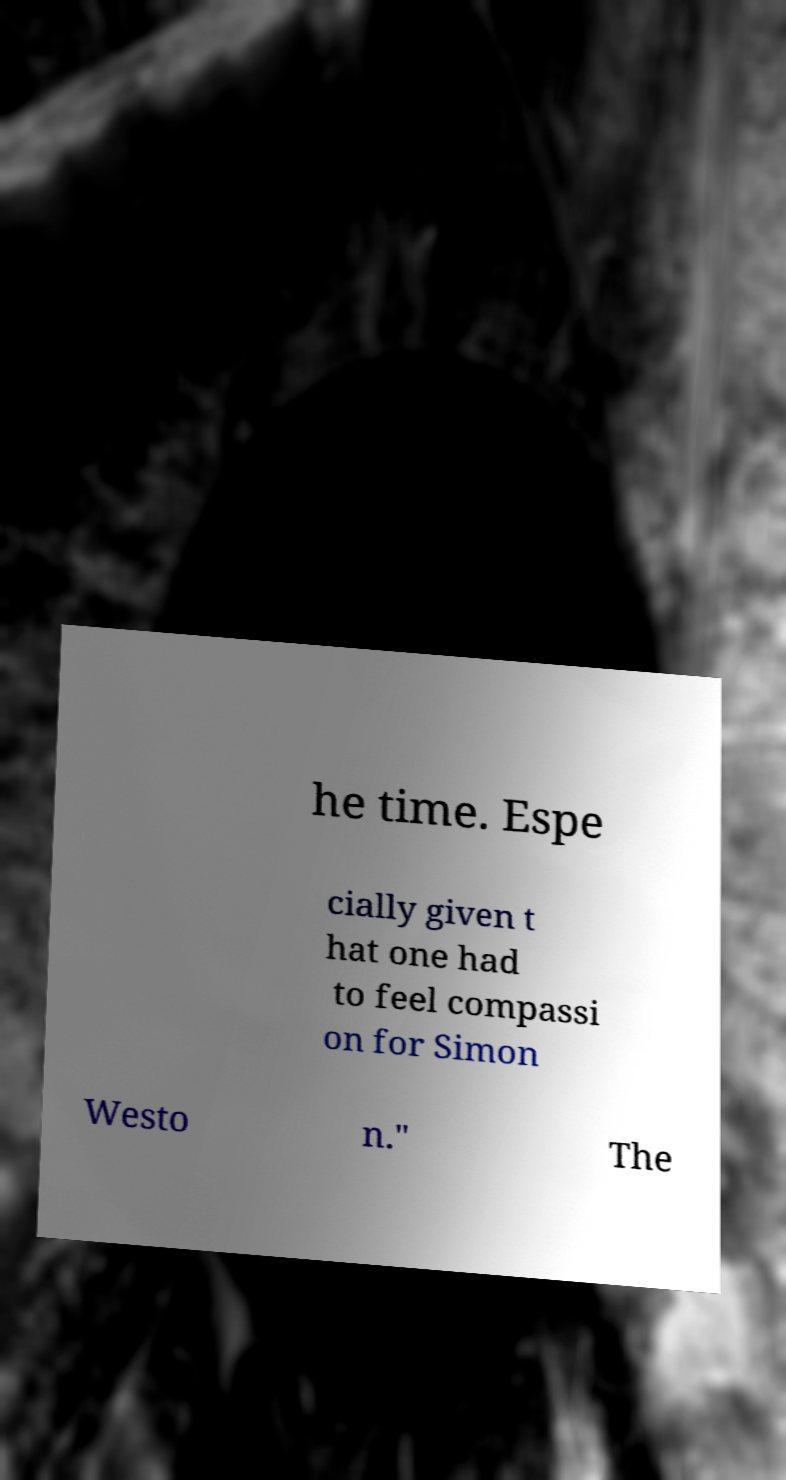Please read and relay the text visible in this image. What does it say? he time. Espe cially given t hat one had to feel compassi on for Simon Westo n." The 